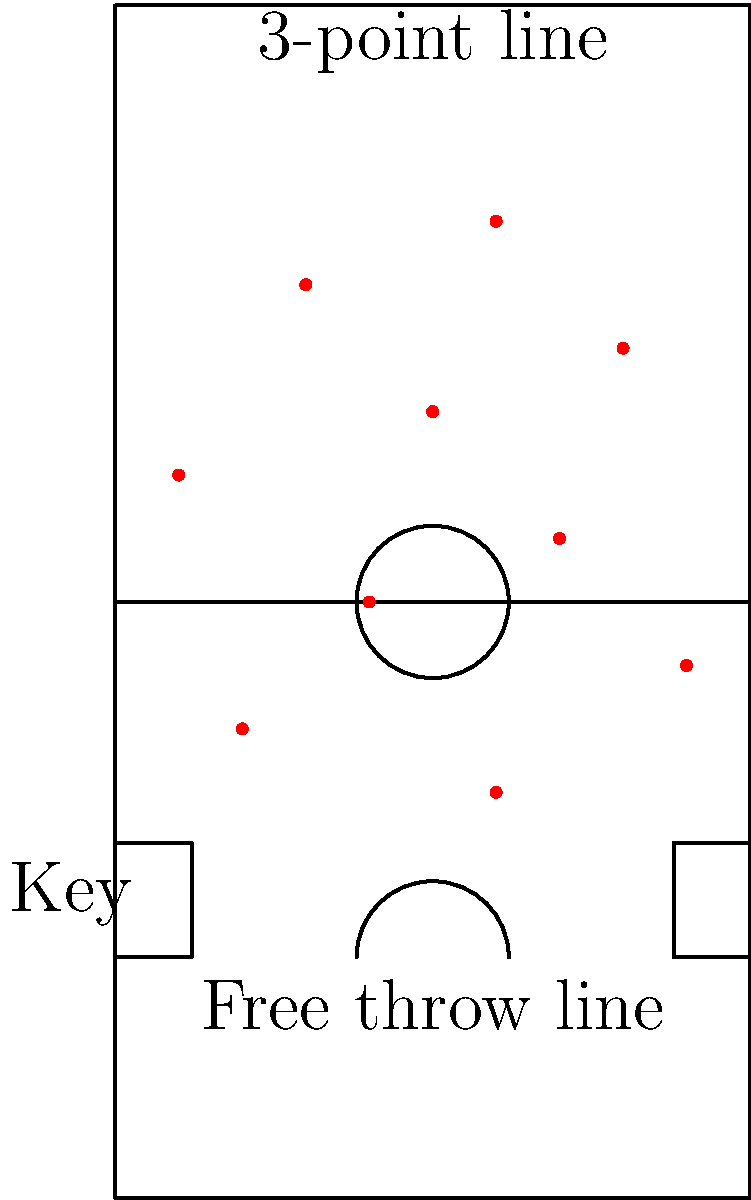Analyze Andrea Diana's shot distribution as depicted in the basketball court diagram. Calculate the percentage of his shots taken from beyond the 3-point line and discuss how this might reflect his playing style for Virtus Bologna. To analyze Andrea Diana's shot distribution and calculate the percentage of 3-point shots:

1. Count the total number of shots:
   There are 10 shots marked on the diagram.

2. Identify 3-point shots:
   Shots beyond the 3-point line (the arc at the top of the key) are 3-pointers.
   There are 3 shots beyond this line.

3. Calculate the percentage:
   Percentage = (Number of 3-point shots / Total shots) * 100
   = (3 / 10) * 100 = 30%

4. Analyze the distribution:
   - 30% of shots are from 3-point range
   - 70% are from inside the 3-point line
   - There's a good spread of shots across different areas of the court

5. Interpret playing style:
   - Diana shows versatility, taking shots from various distances
   - He's not overly reliant on 3-pointers, suggesting a balanced offensive approach
   - The even distribution indicates he can create scoring opportunities from different positions

6. Consider impact on Virtus Bologna:
   - Diana's varied shot selection makes him unpredictable for defenders
   - His ability to score from different areas could help spread the defense
   - The balanced approach aligns with European basketball's emphasis on all-around skills

This analysis suggests Andrea Diana is a well-rounded shooter who contributes to Virtus Bologna's offense through diverse scoring options.
Answer: 30% 3-pointers; versatile, balanced scorer for Virtus Bologna 